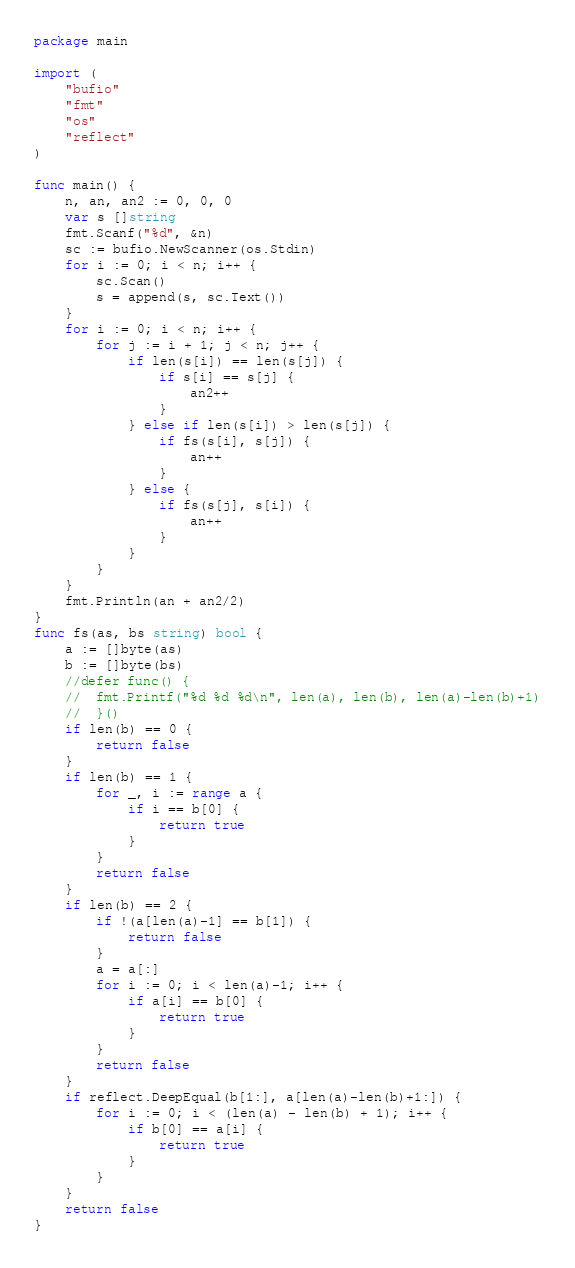Convert code to text. <code><loc_0><loc_0><loc_500><loc_500><_Go_>package main

import (
	"bufio"
	"fmt"
	"os"
	"reflect"
)

func main() {
	n, an, an2 := 0, 0, 0
	var s []string
	fmt.Scanf("%d", &n)
	sc := bufio.NewScanner(os.Stdin)
	for i := 0; i < n; i++ {
		sc.Scan()
		s = append(s, sc.Text())
	}
	for i := 0; i < n; i++ {
		for j := i + 1; j < n; j++ {
			if len(s[i]) == len(s[j]) {
				if s[i] == s[j] {
					an2++
				}
			} else if len(s[i]) > len(s[j]) {
				if fs(s[i], s[j]) {
					an++
				}
			} else {
				if fs(s[j], s[i]) {
					an++
				}
			}
		}
	}
	fmt.Println(an + an2/2)
}
func fs(as, bs string) bool {
	a := []byte(as)
	b := []byte(bs)
	//defer func() {
	//	fmt.Printf("%d %d %d\n", len(a), len(b), len(a)-len(b)+1)
	//	}()
	if len(b) == 0 {
		return false
	}
	if len(b) == 1 {
		for _, i := range a {
			if i == b[0] {
				return true
			}
		}
		return false
	}
	if len(b) == 2 {
		if !(a[len(a)-1] == b[1]) {
			return false
		}
		a = a[:]
		for i := 0; i < len(a)-1; i++ {
			if a[i] == b[0] {
				return true
			}
		}
		return false
	}
	if reflect.DeepEqual(b[1:], a[len(a)-len(b)+1:]) {
		for i := 0; i < (len(a) - len(b) + 1); i++ {
			if b[0] == a[i] {
				return true
			}
		}
	}
	return false
}
</code> 